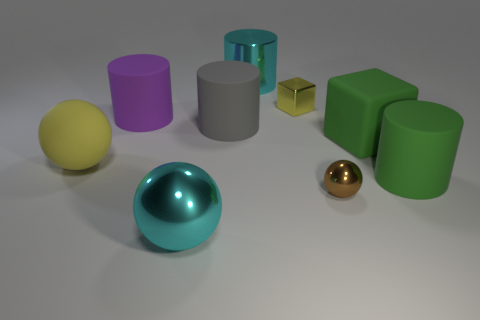The large rubber thing that is the same shape as the small brown thing is what color? yellow 